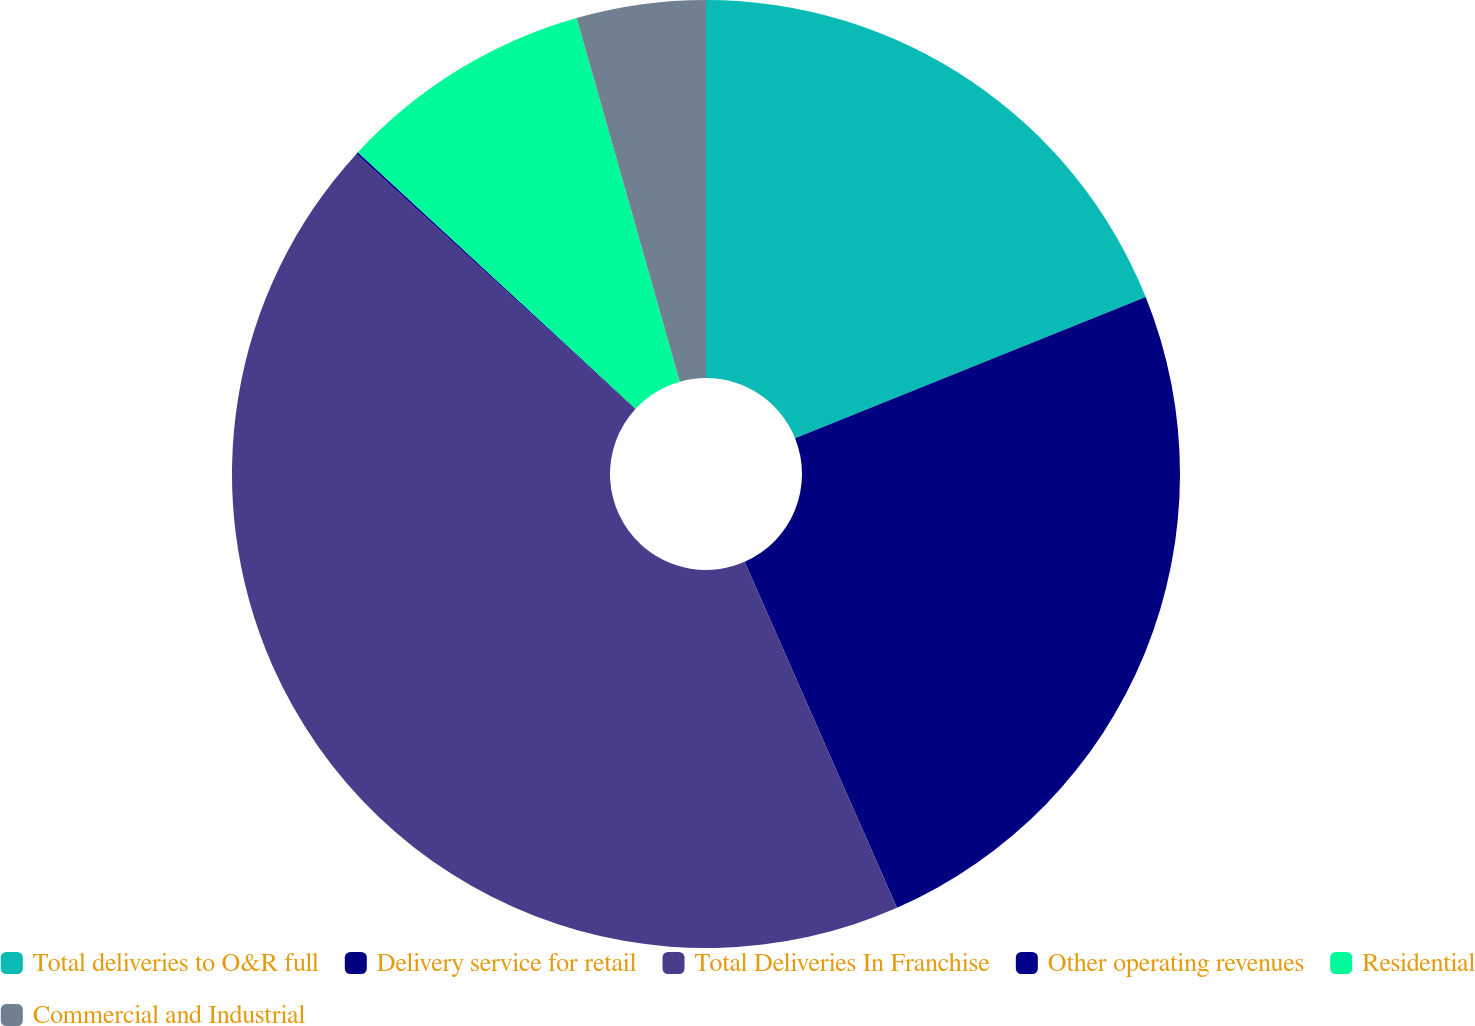<chart> <loc_0><loc_0><loc_500><loc_500><pie_chart><fcel>Total deliveries to O&R full<fcel>Delivery service for retail<fcel>Total Deliveries In Franchise<fcel>Other operating revenues<fcel>Residential<fcel>Commercial and Industrial<nl><fcel>18.91%<fcel>24.49%<fcel>43.4%<fcel>0.07%<fcel>8.73%<fcel>4.4%<nl></chart> 